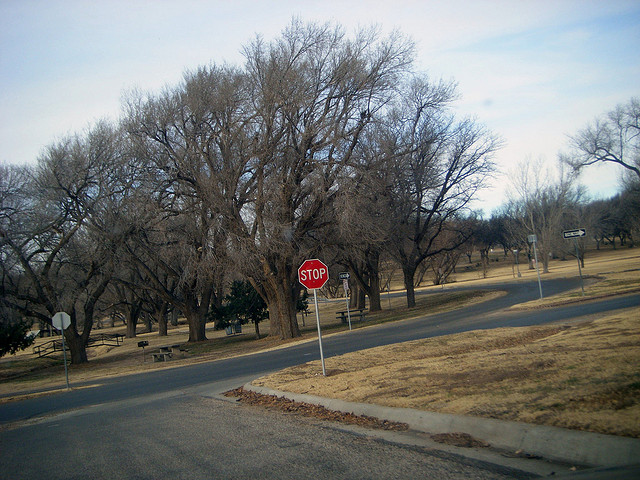Please transcribe the text in this image. STOP 